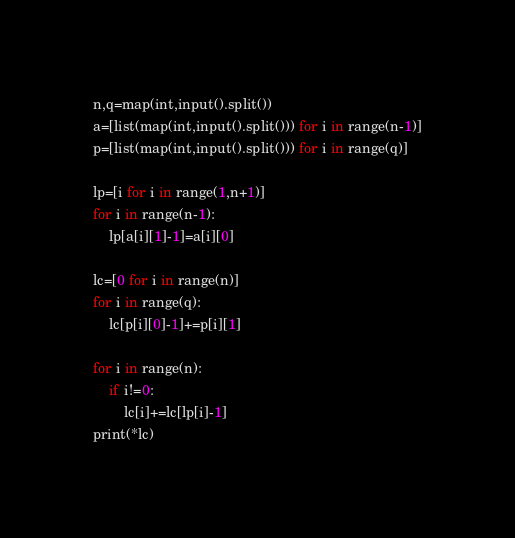<code> <loc_0><loc_0><loc_500><loc_500><_Python_>n,q=map(int,input().split())
a=[list(map(int,input().split())) for i in range(n-1)]
p=[list(map(int,input().split())) for i in range(q)]

lp=[i for i in range(1,n+1)]
for i in range(n-1):
    lp[a[i][1]-1]=a[i][0]

lc=[0 for i in range(n)]
for i in range(q):
    lc[p[i][0]-1]+=p[i][1]

for i in range(n):
    if i!=0:
        lc[i]+=lc[lp[i]-1]
print(*lc)</code> 